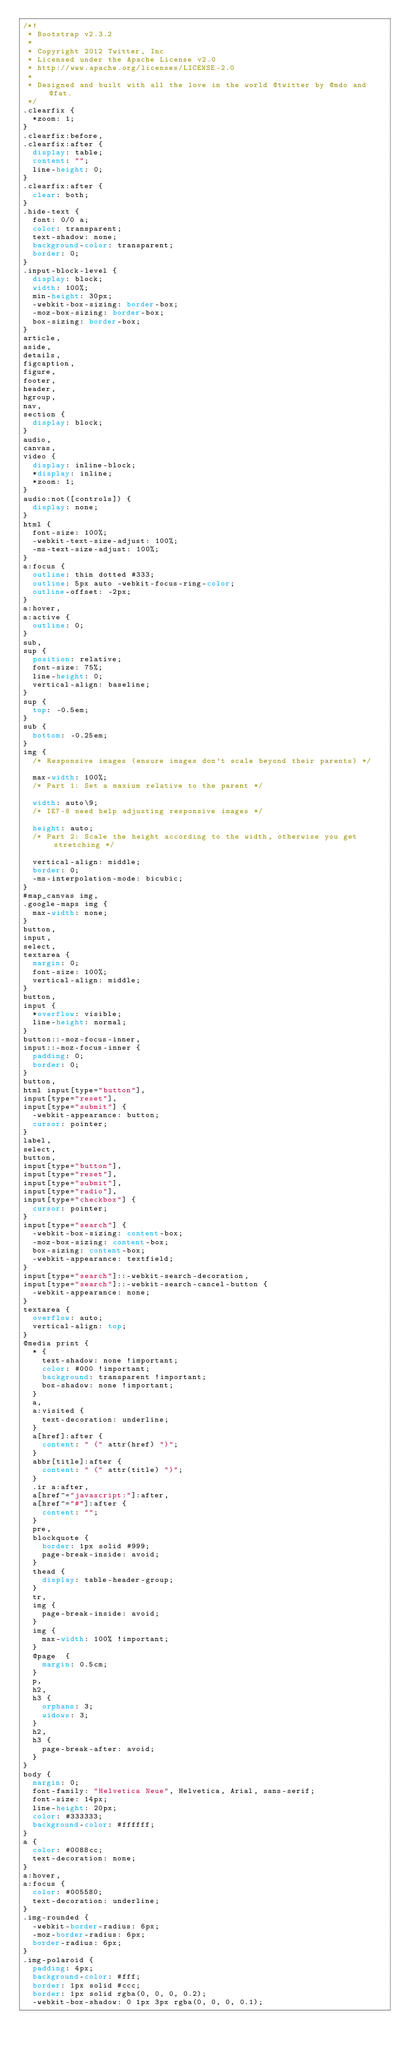Convert code to text. <code><loc_0><loc_0><loc_500><loc_500><_CSS_>/*!
 * Bootstrap v2.3.2
 *
 * Copyright 2012 Twitter, Inc
 * Licensed under the Apache License v2.0
 * http://www.apache.org/licenses/LICENSE-2.0
 *
 * Designed and built with all the love in the world @twitter by @mdo and @fat.
 */
.clearfix {
  *zoom: 1;
}
.clearfix:before,
.clearfix:after {
  display: table;
  content: "";
  line-height: 0;
}
.clearfix:after {
  clear: both;
}
.hide-text {
  font: 0/0 a;
  color: transparent;
  text-shadow: none;
  background-color: transparent;
  border: 0;
}
.input-block-level {
  display: block;
  width: 100%;
  min-height: 30px;
  -webkit-box-sizing: border-box;
  -moz-box-sizing: border-box;
  box-sizing: border-box;
}
article,
aside,
details,
figcaption,
figure,
footer,
header,
hgroup,
nav,
section {
  display: block;
}
audio,
canvas,
video {
  display: inline-block;
  *display: inline;
  *zoom: 1;
}
audio:not([controls]) {
  display: none;
}
html {
  font-size: 100%;
  -webkit-text-size-adjust: 100%;
  -ms-text-size-adjust: 100%;
}
a:focus {
  outline: thin dotted #333;
  outline: 5px auto -webkit-focus-ring-color;
  outline-offset: -2px;
}
a:hover,
a:active {
  outline: 0;
}
sub,
sup {
  position: relative;
  font-size: 75%;
  line-height: 0;
  vertical-align: baseline;
}
sup {
  top: -0.5em;
}
sub {
  bottom: -0.25em;
}
img {
  /* Responsive images (ensure images don't scale beyond their parents) */

  max-width: 100%;
  /* Part 1: Set a maxium relative to the parent */

  width: auto\9;
  /* IE7-8 need help adjusting responsive images */

  height: auto;
  /* Part 2: Scale the height according to the width, otherwise you get stretching */

  vertical-align: middle;
  border: 0;
  -ms-interpolation-mode: bicubic;
}
#map_canvas img,
.google-maps img {
  max-width: none;
}
button,
input,
select,
textarea {
  margin: 0;
  font-size: 100%;
  vertical-align: middle;
}
button,
input {
  *overflow: visible;
  line-height: normal;
}
button::-moz-focus-inner,
input::-moz-focus-inner {
  padding: 0;
  border: 0;
}
button,
html input[type="button"],
input[type="reset"],
input[type="submit"] {
  -webkit-appearance: button;
  cursor: pointer;
}
label,
select,
button,
input[type="button"],
input[type="reset"],
input[type="submit"],
input[type="radio"],
input[type="checkbox"] {
  cursor: pointer;
}
input[type="search"] {
  -webkit-box-sizing: content-box;
  -moz-box-sizing: content-box;
  box-sizing: content-box;
  -webkit-appearance: textfield;
}
input[type="search"]::-webkit-search-decoration,
input[type="search"]::-webkit-search-cancel-button {
  -webkit-appearance: none;
}
textarea {
  overflow: auto;
  vertical-align: top;
}
@media print {
  * {
    text-shadow: none !important;
    color: #000 !important;
    background: transparent !important;
    box-shadow: none !important;
  }
  a,
  a:visited {
    text-decoration: underline;
  }
  a[href]:after {
    content: " (" attr(href) ")";
  }
  abbr[title]:after {
    content: " (" attr(title) ")";
  }
  .ir a:after,
  a[href^="javascript:"]:after,
  a[href^="#"]:after {
    content: "";
  }
  pre,
  blockquote {
    border: 1px solid #999;
    page-break-inside: avoid;
  }
  thead {
    display: table-header-group;
  }
  tr,
  img {
    page-break-inside: avoid;
  }
  img {
    max-width: 100% !important;
  }
  @page  {
    margin: 0.5cm;
  }
  p,
  h2,
  h3 {
    orphans: 3;
    widows: 3;
  }
  h2,
  h3 {
    page-break-after: avoid;
  }
}
body {
  margin: 0;
  font-family: "Helvetica Neue", Helvetica, Arial, sans-serif;
  font-size: 14px;
  line-height: 20px;
  color: #333333;
  background-color: #ffffff;
}
a {
  color: #0088cc;
  text-decoration: none;
}
a:hover,
a:focus {
  color: #005580;
  text-decoration: underline;
}
.img-rounded {
  -webkit-border-radius: 6px;
  -moz-border-radius: 6px;
  border-radius: 6px;
}
.img-polaroid {
  padding: 4px;
  background-color: #fff;
  border: 1px solid #ccc;
  border: 1px solid rgba(0, 0, 0, 0.2);
  -webkit-box-shadow: 0 1px 3px rgba(0, 0, 0, 0.1);</code> 